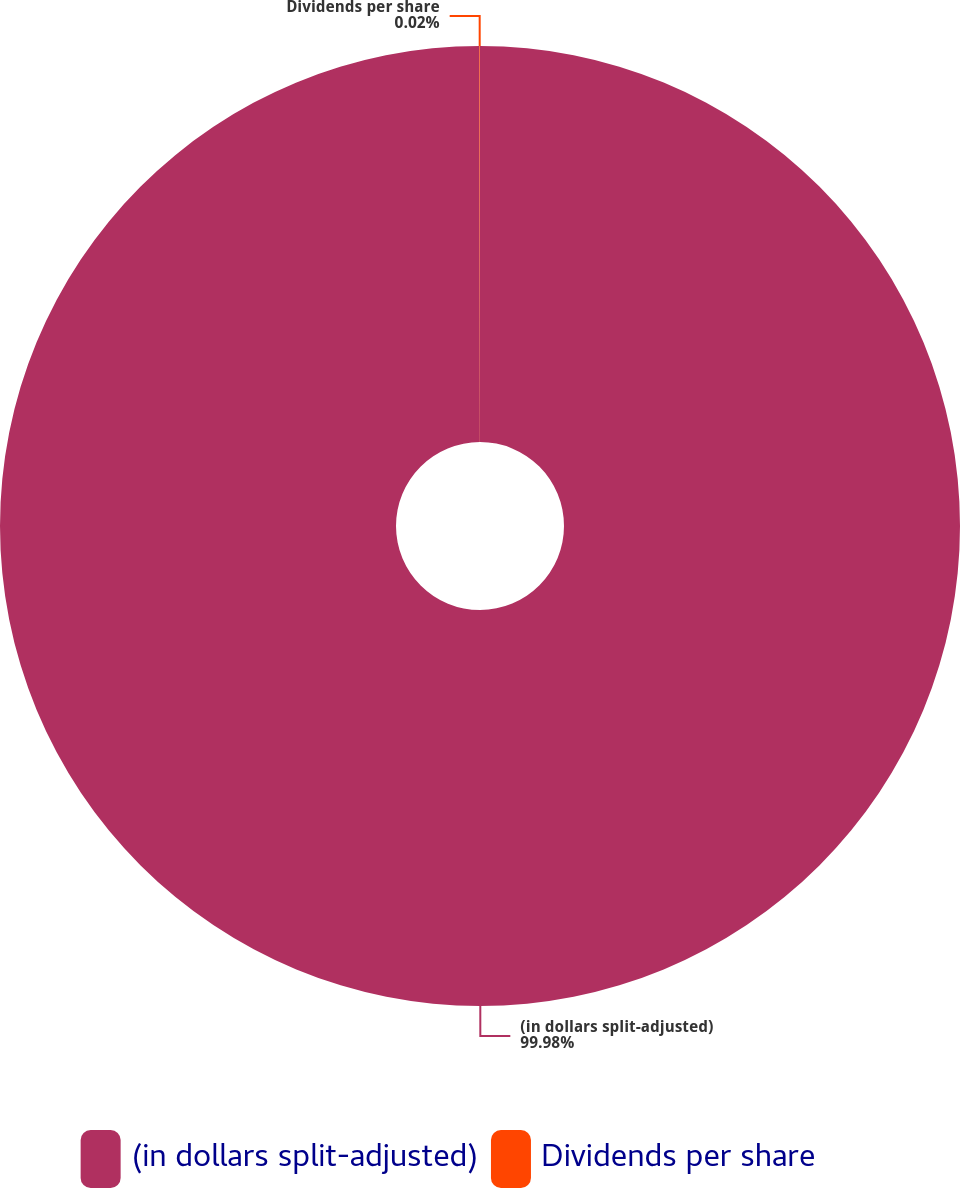<chart> <loc_0><loc_0><loc_500><loc_500><pie_chart><fcel>(in dollars split-adjusted)<fcel>Dividends per share<nl><fcel>99.98%<fcel>0.02%<nl></chart> 